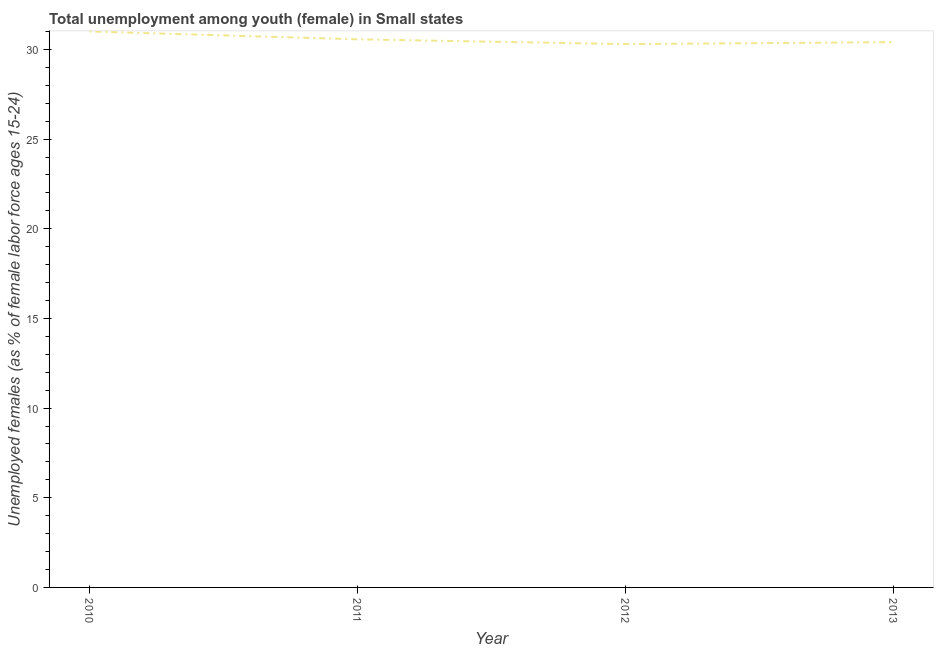What is the unemployed female youth population in 2010?
Keep it short and to the point. 31. Across all years, what is the maximum unemployed female youth population?
Your answer should be very brief. 31. Across all years, what is the minimum unemployed female youth population?
Your answer should be very brief. 30.3. What is the sum of the unemployed female youth population?
Offer a very short reply. 122.27. What is the difference between the unemployed female youth population in 2011 and 2013?
Offer a very short reply. 0.16. What is the average unemployed female youth population per year?
Keep it short and to the point. 30.57. What is the median unemployed female youth population?
Ensure brevity in your answer.  30.49. In how many years, is the unemployed female youth population greater than 8 %?
Make the answer very short. 4. What is the ratio of the unemployed female youth population in 2011 to that in 2013?
Offer a very short reply. 1.01. Is the unemployed female youth population in 2011 less than that in 2012?
Your answer should be compact. No. What is the difference between the highest and the second highest unemployed female youth population?
Provide a succinct answer. 0.44. What is the difference between the highest and the lowest unemployed female youth population?
Offer a very short reply. 0.71. In how many years, is the unemployed female youth population greater than the average unemployed female youth population taken over all years?
Your answer should be compact. 1. Does the unemployed female youth population monotonically increase over the years?
Offer a very short reply. No. How many lines are there?
Provide a succinct answer. 1. What is the difference between two consecutive major ticks on the Y-axis?
Keep it short and to the point. 5. Are the values on the major ticks of Y-axis written in scientific E-notation?
Ensure brevity in your answer.  No. Does the graph contain any zero values?
Your response must be concise. No. Does the graph contain grids?
Your response must be concise. No. What is the title of the graph?
Your answer should be very brief. Total unemployment among youth (female) in Small states. What is the label or title of the Y-axis?
Your answer should be very brief. Unemployed females (as % of female labor force ages 15-24). What is the Unemployed females (as % of female labor force ages 15-24) in 2010?
Provide a succinct answer. 31. What is the Unemployed females (as % of female labor force ages 15-24) of 2011?
Your response must be concise. 30.56. What is the Unemployed females (as % of female labor force ages 15-24) of 2012?
Give a very brief answer. 30.3. What is the Unemployed females (as % of female labor force ages 15-24) in 2013?
Your answer should be compact. 30.41. What is the difference between the Unemployed females (as % of female labor force ages 15-24) in 2010 and 2011?
Make the answer very short. 0.44. What is the difference between the Unemployed females (as % of female labor force ages 15-24) in 2010 and 2012?
Your answer should be very brief. 0.71. What is the difference between the Unemployed females (as % of female labor force ages 15-24) in 2010 and 2013?
Offer a very short reply. 0.6. What is the difference between the Unemployed females (as % of female labor force ages 15-24) in 2011 and 2012?
Your response must be concise. 0.27. What is the difference between the Unemployed females (as % of female labor force ages 15-24) in 2011 and 2013?
Your answer should be compact. 0.16. What is the difference between the Unemployed females (as % of female labor force ages 15-24) in 2012 and 2013?
Keep it short and to the point. -0.11. What is the ratio of the Unemployed females (as % of female labor force ages 15-24) in 2011 to that in 2012?
Give a very brief answer. 1.01. 